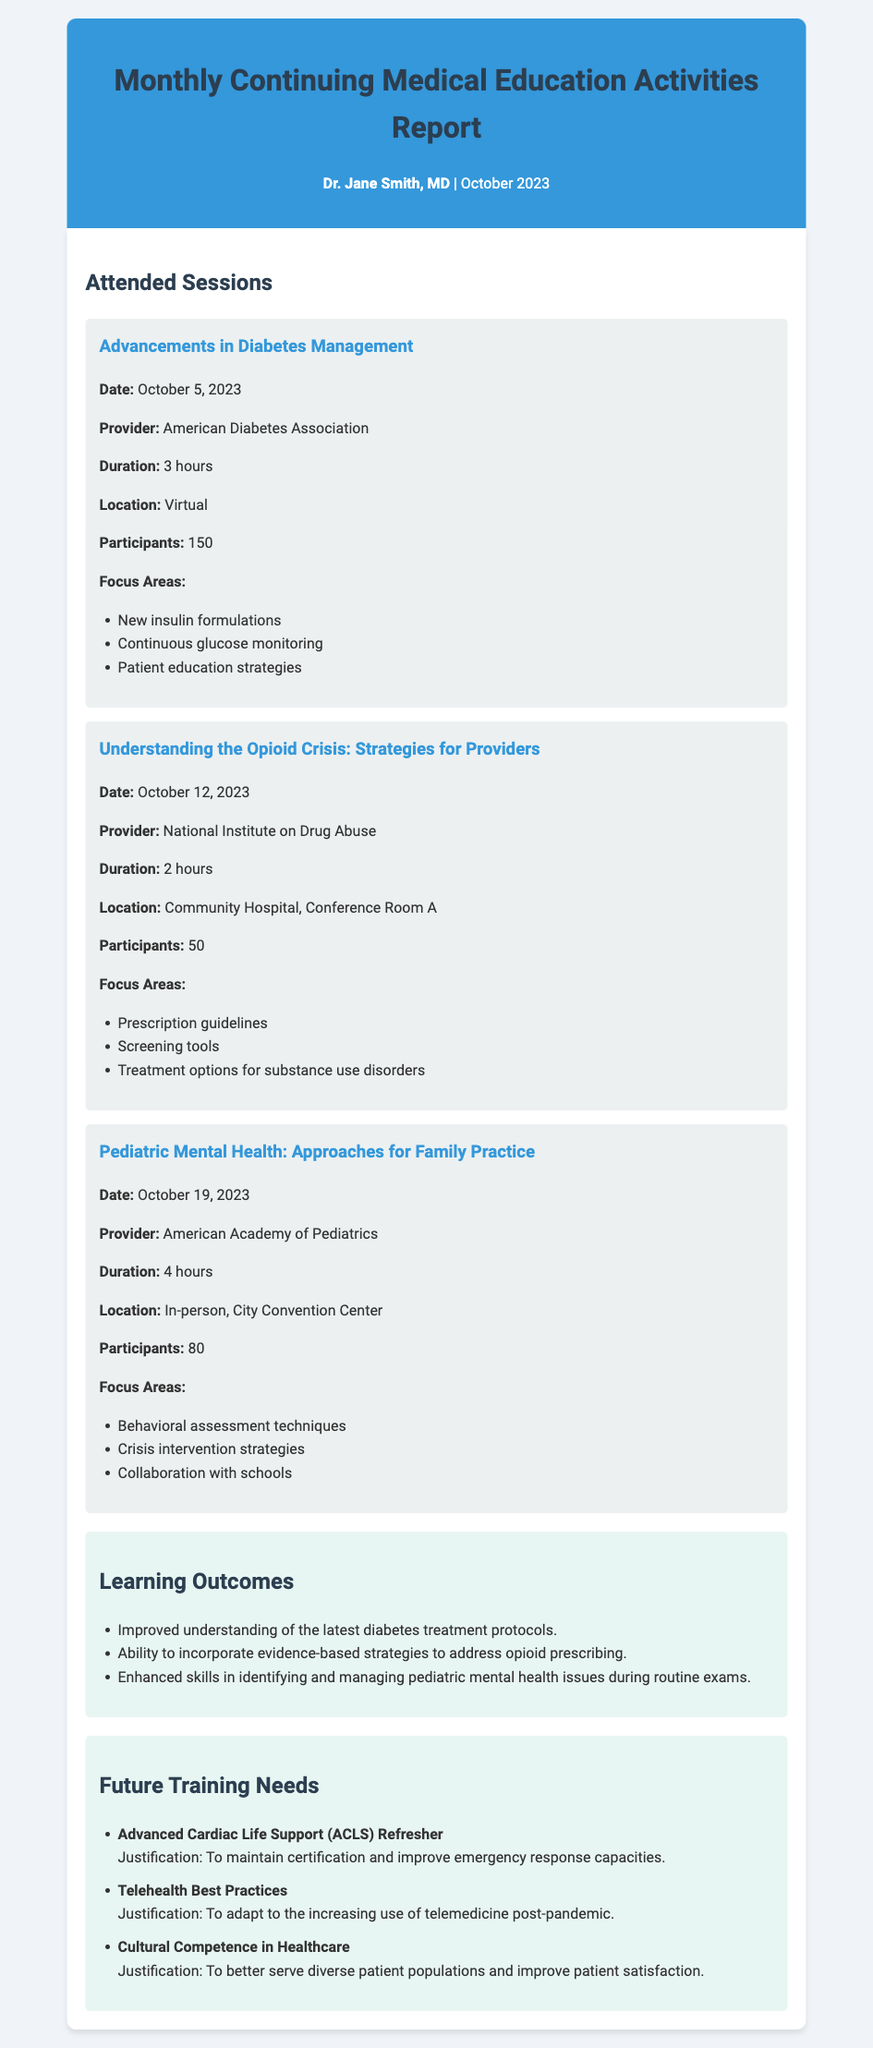What was the date of the session on diabetes management? The date for the session is provided as October 5, 2023.
Answer: October 5, 2023 How many hours did the session on opioid crisis strategies last? The duration of the opioid crisis session is indicated as 2 hours.
Answer: 2 hours What is one of the focus areas for the pediatric mental health session? The document lists several focus areas for this session, including behavioral assessment techniques.
Answer: Behavioral assessment techniques Who provided the session on pediatric mental health? The provider for this session is mentioned as the American Academy of Pediatrics.
Answer: American Academy of Pediatrics What learning outcome relates to pediatric mental health? The learning outcome notes enhanced skills in identifying and managing pediatric mental health issues during routine exams.
Answer: Enhanced skills in identifying and managing pediatric mental health issues What is one of the future training needs listed? The memo lists several future training needs, one of which is the Advanced Cardiac Life Support (ACLS) Refresher.
Answer: Advanced Cardiac Life Support (ACLS) Refresher Why is the ACLS refresher needed? The justification for the ACLS refresher is to maintain certification and improve emergency response capacities.
Answer: To maintain certification and improve emergency response capacities How many participants attended the diabetes management session? The document states that there were 150 participants in the diabetes management session.
Answer: 150 What was the location for the session on opioid crisis strategies? The location for this session is identified in the document as Community Hospital, Conference Room A.
Answer: Community Hospital, Conference Room A 